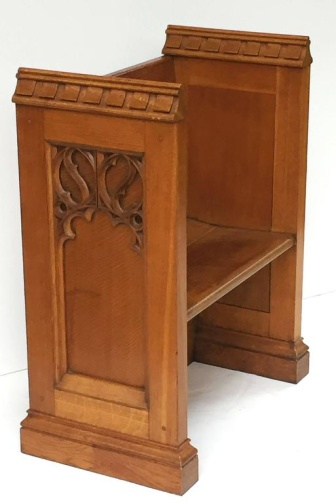Describe the cultural or historical significance that this bench might have. This bench, with its intricate wooden carvings and robust construction, may reflect a particular style from a bygone era. Such benches were often found in ecclesiastical settings, such as churches or monasteries, serving as seating for congregations. The careful craftsmanship and attention to detail suggest that it could also have been part of a wealthy household, used in a formal area like a study or a parlor. The carvings could symbolize religious belief, artisan guilds, or simply the aesthetic preferences of the period. Without further context, it stands as a beautiful example of historical woodworking skills. Imagine a grand hall where this bench is placed. What might the rest of the room look like? Picture a grand hall with tall, arched windows letting in streams of light, illuminating the room. The walls are lined with dark wood paneling, matching the style of the bench. Stained glass windows cast colorful patterns on the stone floor. Chandeliers hang from the high, vaulted ceiling, shimmering with an elegant glow. The room is furnished with more wooden pieces, similarly carved, suggesting a cohesive artistic theme. Tapestries depicting historical events or pastoral scenes adorn the walls, adding a touch of warmth and color. In the center, a large table made of sturdy oak sits under the chandelier, surrounded by high-backed chairs. The air in this hall speaks of history, tradition, and a sense of grandeur. 